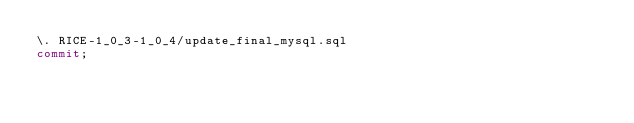<code> <loc_0><loc_0><loc_500><loc_500><_SQL_>\. RICE-1_0_3-1_0_4/update_final_mysql.sql
commit;
</code> 